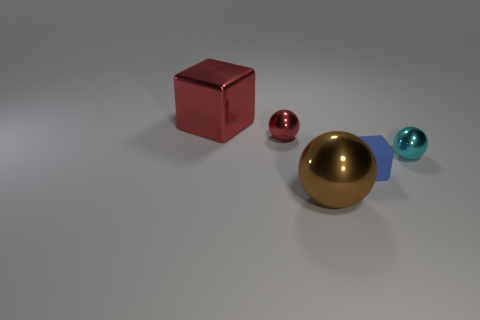Add 2 blue matte things. How many objects exist? 7 Subtract all cubes. How many objects are left? 3 Subtract all large cyan rubber things. Subtract all big brown balls. How many objects are left? 4 Add 2 blue objects. How many blue objects are left? 3 Add 3 red metallic spheres. How many red metallic spheres exist? 4 Subtract 1 red cubes. How many objects are left? 4 